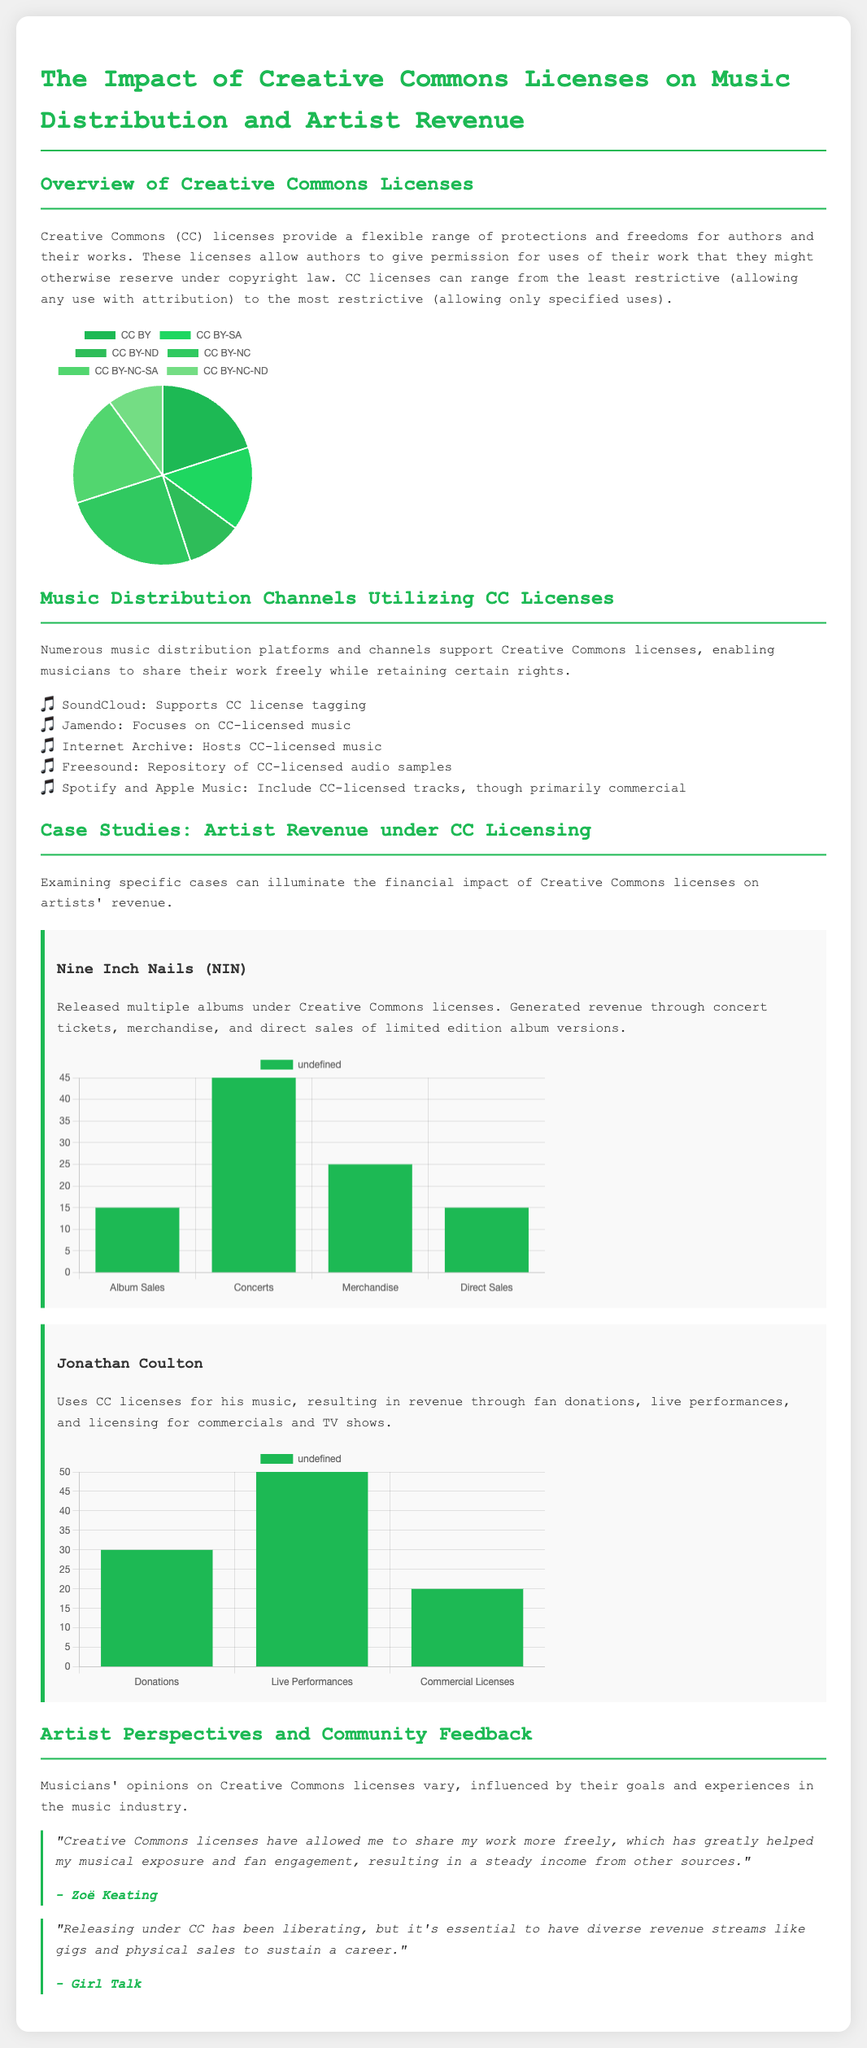What are the types of Creative Commons licenses? The document lists six types of Creative Commons licenses, each with different permissions and restrictions.
Answer: CC BY, CC BY-SA, CC BY-ND, CC BY-NC, CC BY-NC-SA, CC BY-NC-ND Which artist released albums under Creative Commons licenses? Nine Inch Nails is specifically mentioned as an artist who released multiple albums under Creative Commons licenses.
Answer: Nine Inch Nails What revenue stream had the highest percentage for Nine Inch Nails? The document states that concerts generated the highest revenue percentage for Nine Inch Nails.
Answer: Concerts What is the percentage of revenue Jonathan Coulton receives from live performances? The chart indicates that live performances account for 50% of Jonathan Coulton's revenue.
Answer: 50% Which platform focuses on CC-licensed music? The document mentions Jamendo as a platform that focuses specifically on Creative Commons-licensed music.
Answer: Jamendo What percentage of Creative Commons licenses is CC BY? According to the pie chart, CC BY constitutes 20% of the distribution of Creative Commons licenses.
Answer: 20% Who provided a quote about the benefits of Creative Commons licensing? The document includes a quote from Zoë Keating discussing her positive experience with Creative Commons licenses.
Answer: Zoë Keating What are the revenue streams for Jonathan Coulton? The document lists donations, live performances, and commercial licenses as Jonathan Coulton's revenue streams.
Answer: Donations, Live Performances, Commercial Licenses 